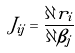Convert formula to latex. <formula><loc_0><loc_0><loc_500><loc_500>J _ { i j } = { \frac { \partial r _ { i } } { \partial \beta _ { j } } }</formula> 